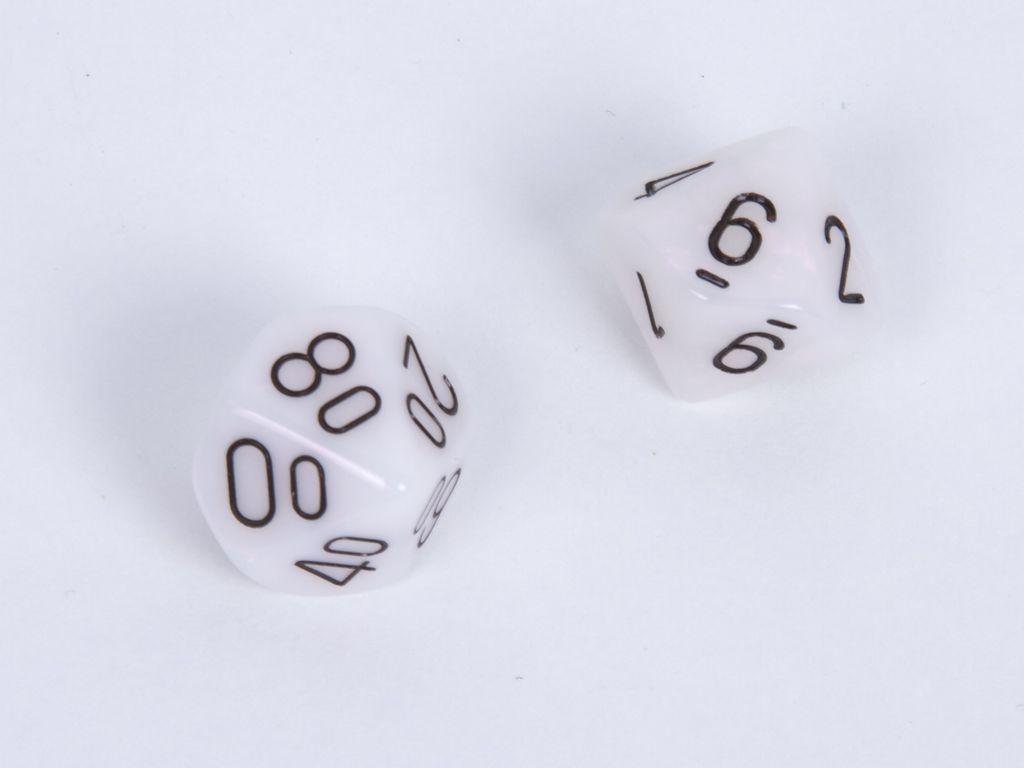What objects are present in the image? There are two dice in the image. Can you describe the appearance of the dice? The dice are typically cubical in shape with dots on each side. What might the dice be used for in the image? The dice could be used for games or activities that involve chance or randomization. What territory is being claimed by the dice in the image? There is no territory being claimed by the dice in the image, as dice are inanimate objects and do not have the ability to claim territories. 